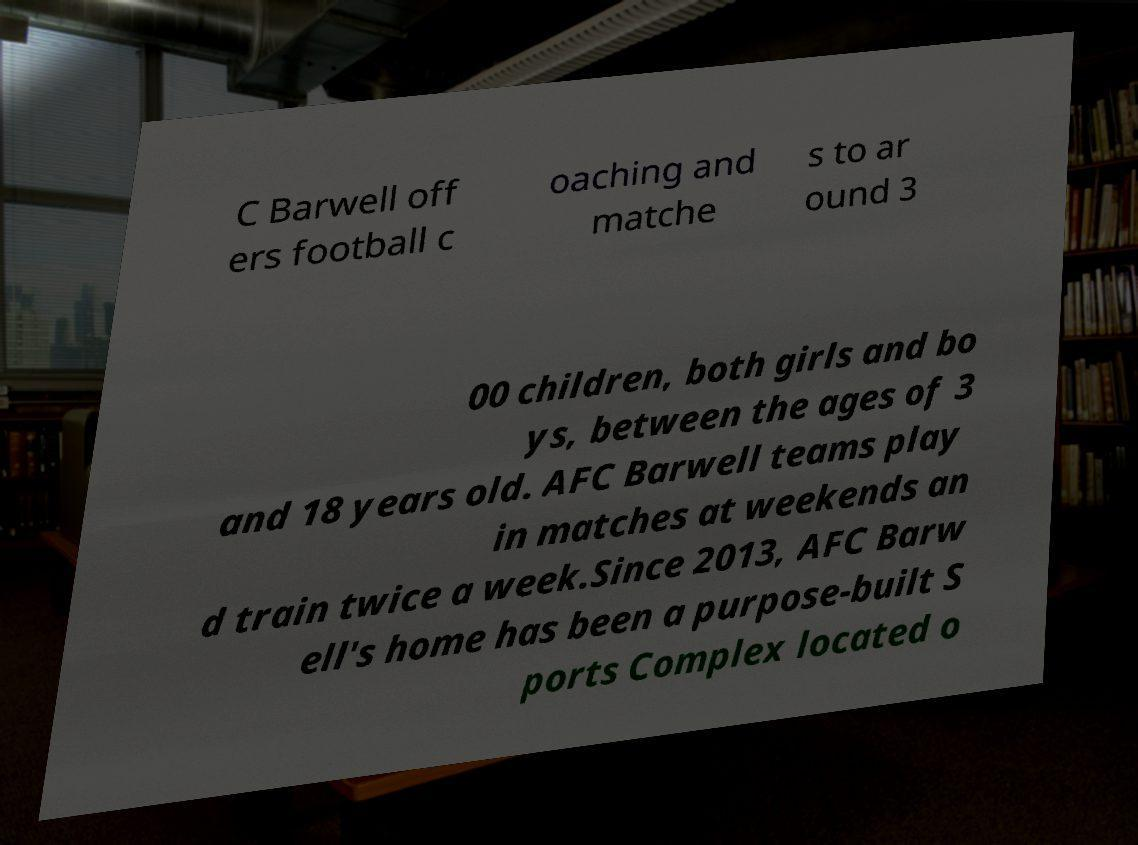What messages or text are displayed in this image? I need them in a readable, typed format. C Barwell off ers football c oaching and matche s to ar ound 3 00 children, both girls and bo ys, between the ages of 3 and 18 years old. AFC Barwell teams play in matches at weekends an d train twice a week.Since 2013, AFC Barw ell's home has been a purpose-built S ports Complex located o 